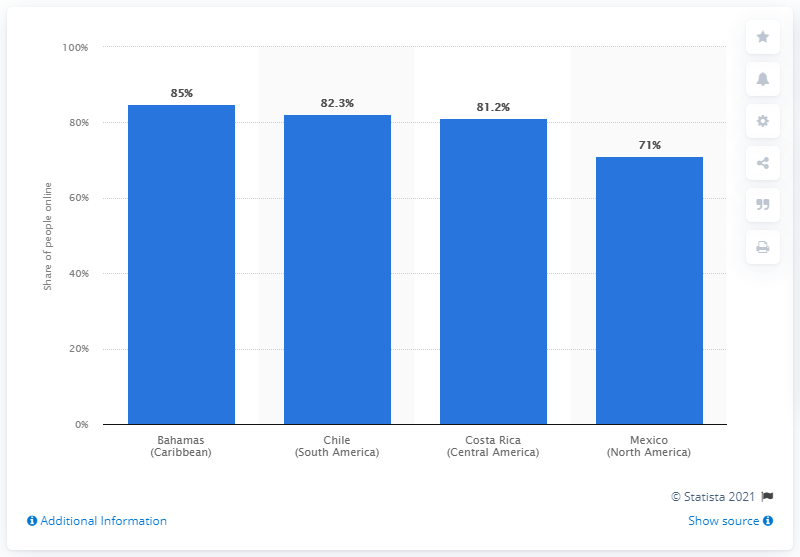Specify some key components in this picture. In 2021, 82.3% of Chileans were connected to the internet. 